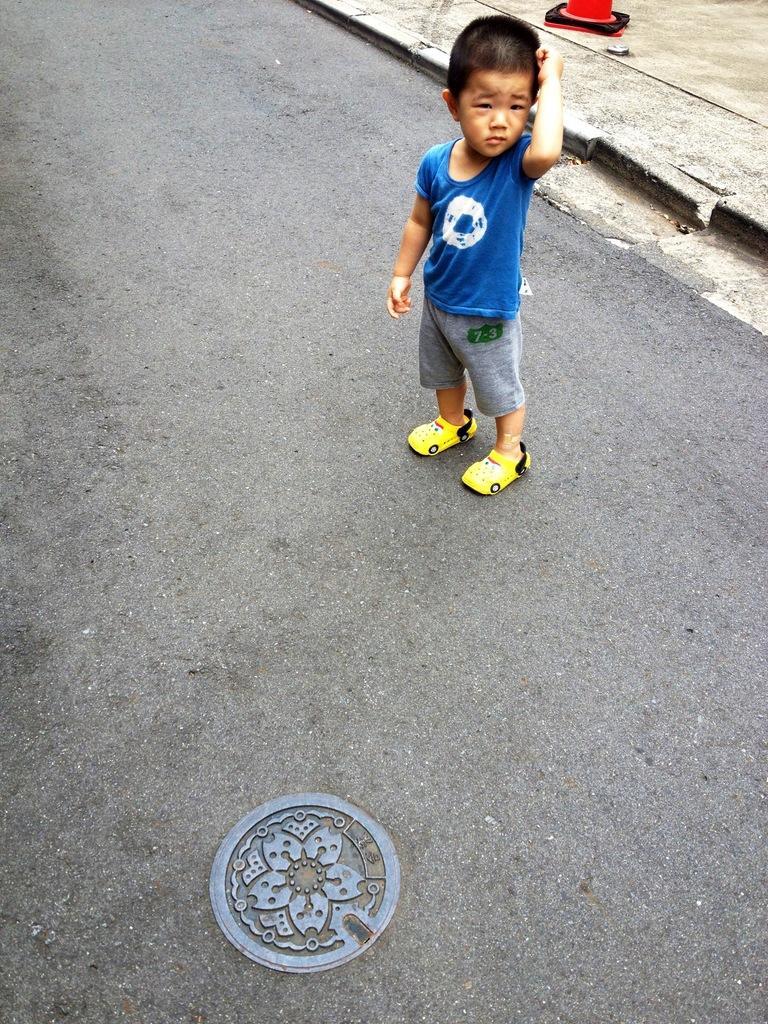Please provide a concise description of this image. In this image, we can see a kid is standing on the road. Top of the image, we can see a walkway and red object. At the bottom, we can see a manhole. 